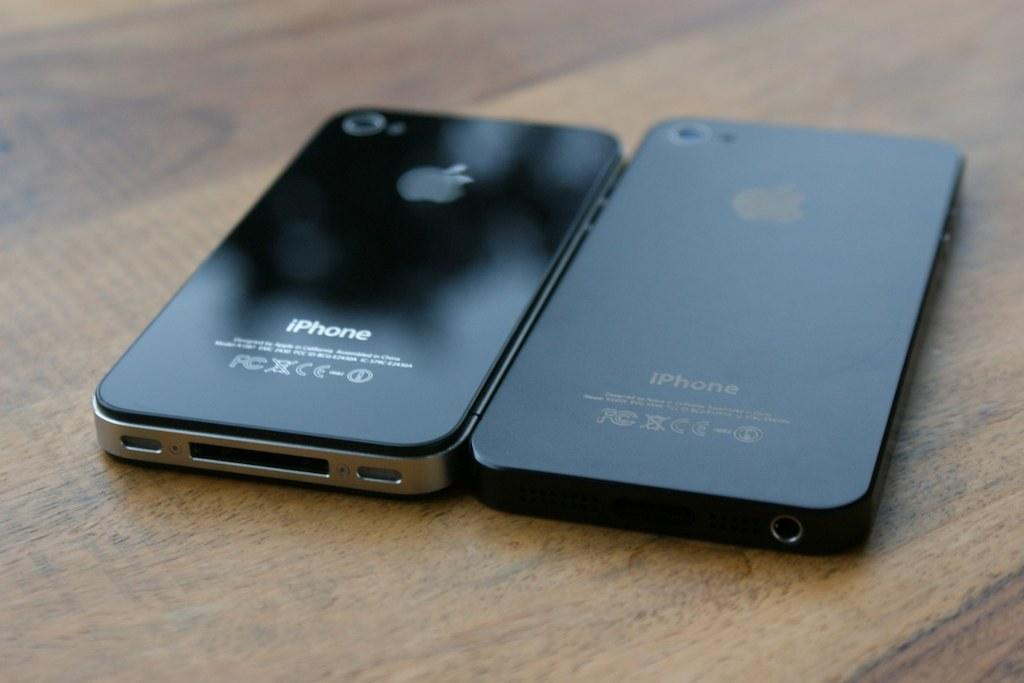<image>
Summarize the visual content of the image. Two black iphones laid face down on a table 